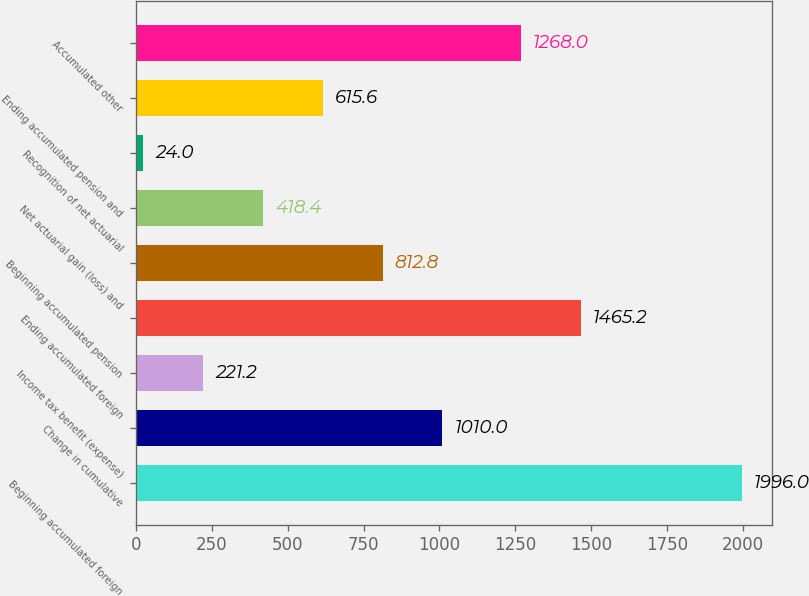<chart> <loc_0><loc_0><loc_500><loc_500><bar_chart><fcel>Beginning accumulated foreign<fcel>Change in cumulative<fcel>Income tax benefit (expense)<fcel>Ending accumulated foreign<fcel>Beginning accumulated pension<fcel>Net actuarial gain (loss) and<fcel>Recognition of net actuarial<fcel>Ending accumulated pension and<fcel>Accumulated other<nl><fcel>1996<fcel>1010<fcel>221.2<fcel>1465.2<fcel>812.8<fcel>418.4<fcel>24<fcel>615.6<fcel>1268<nl></chart> 